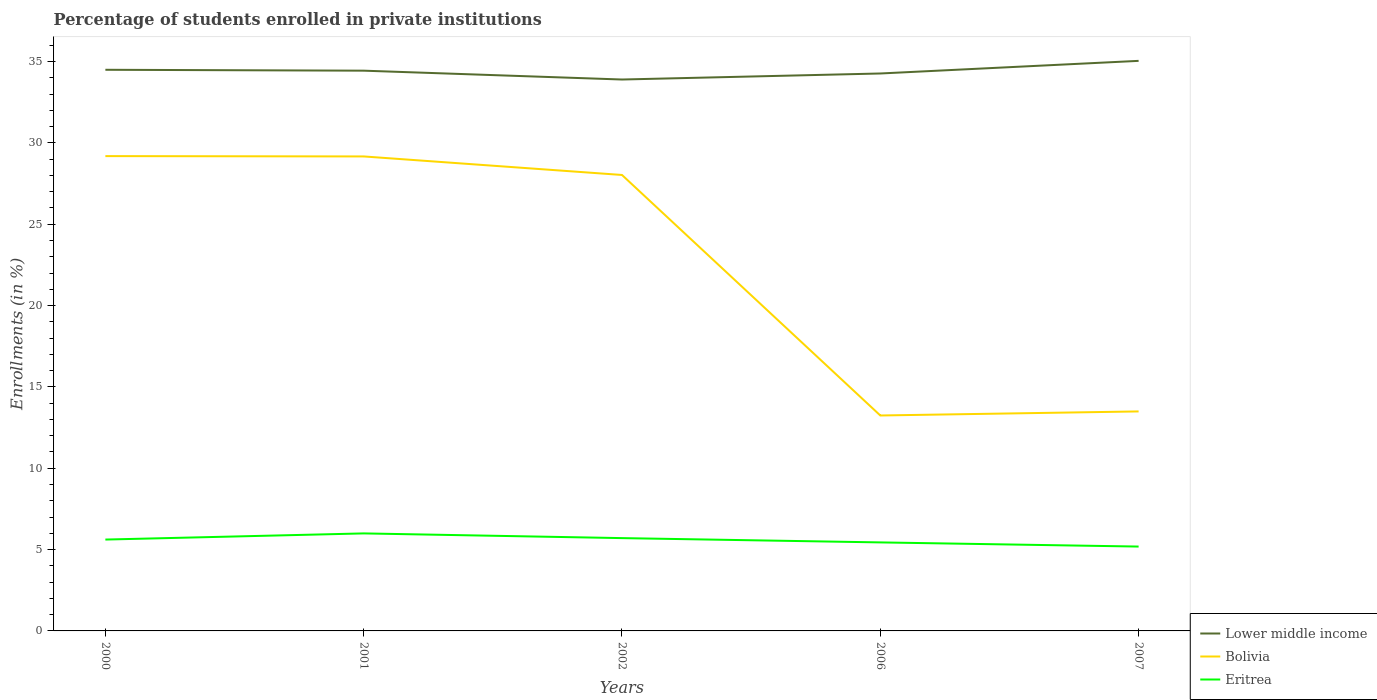Does the line corresponding to Bolivia intersect with the line corresponding to Eritrea?
Offer a very short reply. No. Across all years, what is the maximum percentage of trained teachers in Bolivia?
Your answer should be compact. 13.24. What is the total percentage of trained teachers in Lower middle income in the graph?
Your response must be concise. 0.54. What is the difference between the highest and the second highest percentage of trained teachers in Eritrea?
Offer a terse response. 0.81. What is the difference between the highest and the lowest percentage of trained teachers in Eritrea?
Keep it short and to the point. 3. Is the percentage of trained teachers in Bolivia strictly greater than the percentage of trained teachers in Eritrea over the years?
Your answer should be very brief. No. Are the values on the major ticks of Y-axis written in scientific E-notation?
Your answer should be compact. No. Does the graph contain any zero values?
Offer a very short reply. No. Does the graph contain grids?
Your response must be concise. No. Where does the legend appear in the graph?
Keep it short and to the point. Bottom right. How many legend labels are there?
Offer a terse response. 3. How are the legend labels stacked?
Offer a very short reply. Vertical. What is the title of the graph?
Ensure brevity in your answer.  Percentage of students enrolled in private institutions. Does "Bangladesh" appear as one of the legend labels in the graph?
Offer a terse response. No. What is the label or title of the Y-axis?
Your answer should be very brief. Enrollments (in %). What is the Enrollments (in %) in Lower middle income in 2000?
Ensure brevity in your answer.  34.49. What is the Enrollments (in %) in Bolivia in 2000?
Offer a very short reply. 29.19. What is the Enrollments (in %) of Eritrea in 2000?
Give a very brief answer. 5.62. What is the Enrollments (in %) in Lower middle income in 2001?
Your response must be concise. 34.44. What is the Enrollments (in %) in Bolivia in 2001?
Offer a terse response. 29.17. What is the Enrollments (in %) of Eritrea in 2001?
Provide a short and direct response. 5.99. What is the Enrollments (in %) in Lower middle income in 2002?
Provide a succinct answer. 33.89. What is the Enrollments (in %) of Bolivia in 2002?
Your answer should be compact. 28.03. What is the Enrollments (in %) in Eritrea in 2002?
Make the answer very short. 5.71. What is the Enrollments (in %) of Lower middle income in 2006?
Offer a terse response. 34.26. What is the Enrollments (in %) in Bolivia in 2006?
Offer a terse response. 13.24. What is the Enrollments (in %) of Eritrea in 2006?
Your answer should be compact. 5.44. What is the Enrollments (in %) in Lower middle income in 2007?
Ensure brevity in your answer.  35.04. What is the Enrollments (in %) of Bolivia in 2007?
Your answer should be very brief. 13.49. What is the Enrollments (in %) in Eritrea in 2007?
Provide a succinct answer. 5.19. Across all years, what is the maximum Enrollments (in %) of Lower middle income?
Give a very brief answer. 35.04. Across all years, what is the maximum Enrollments (in %) of Bolivia?
Give a very brief answer. 29.19. Across all years, what is the maximum Enrollments (in %) in Eritrea?
Provide a succinct answer. 5.99. Across all years, what is the minimum Enrollments (in %) in Lower middle income?
Your answer should be very brief. 33.89. Across all years, what is the minimum Enrollments (in %) in Bolivia?
Give a very brief answer. 13.24. Across all years, what is the minimum Enrollments (in %) of Eritrea?
Offer a very short reply. 5.19. What is the total Enrollments (in %) in Lower middle income in the graph?
Offer a terse response. 172.13. What is the total Enrollments (in %) in Bolivia in the graph?
Make the answer very short. 113.11. What is the total Enrollments (in %) of Eritrea in the graph?
Make the answer very short. 27.94. What is the difference between the Enrollments (in %) of Lower middle income in 2000 and that in 2001?
Provide a succinct answer. 0.06. What is the difference between the Enrollments (in %) of Bolivia in 2000 and that in 2001?
Ensure brevity in your answer.  0.02. What is the difference between the Enrollments (in %) in Eritrea in 2000 and that in 2001?
Your answer should be compact. -0.38. What is the difference between the Enrollments (in %) of Lower middle income in 2000 and that in 2002?
Ensure brevity in your answer.  0.6. What is the difference between the Enrollments (in %) of Bolivia in 2000 and that in 2002?
Offer a terse response. 1.16. What is the difference between the Enrollments (in %) of Eritrea in 2000 and that in 2002?
Your answer should be compact. -0.09. What is the difference between the Enrollments (in %) in Lower middle income in 2000 and that in 2006?
Your response must be concise. 0.23. What is the difference between the Enrollments (in %) in Bolivia in 2000 and that in 2006?
Provide a short and direct response. 15.94. What is the difference between the Enrollments (in %) of Eritrea in 2000 and that in 2006?
Your answer should be compact. 0.17. What is the difference between the Enrollments (in %) in Lower middle income in 2000 and that in 2007?
Provide a succinct answer. -0.55. What is the difference between the Enrollments (in %) in Bolivia in 2000 and that in 2007?
Provide a short and direct response. 15.69. What is the difference between the Enrollments (in %) of Eritrea in 2000 and that in 2007?
Your answer should be very brief. 0.43. What is the difference between the Enrollments (in %) of Lower middle income in 2001 and that in 2002?
Provide a succinct answer. 0.54. What is the difference between the Enrollments (in %) of Bolivia in 2001 and that in 2002?
Make the answer very short. 1.14. What is the difference between the Enrollments (in %) in Eritrea in 2001 and that in 2002?
Keep it short and to the point. 0.29. What is the difference between the Enrollments (in %) in Lower middle income in 2001 and that in 2006?
Keep it short and to the point. 0.17. What is the difference between the Enrollments (in %) of Bolivia in 2001 and that in 2006?
Ensure brevity in your answer.  15.92. What is the difference between the Enrollments (in %) in Eritrea in 2001 and that in 2006?
Provide a succinct answer. 0.55. What is the difference between the Enrollments (in %) in Lower middle income in 2001 and that in 2007?
Offer a terse response. -0.6. What is the difference between the Enrollments (in %) of Bolivia in 2001 and that in 2007?
Provide a short and direct response. 15.67. What is the difference between the Enrollments (in %) of Eritrea in 2001 and that in 2007?
Your answer should be compact. 0.81. What is the difference between the Enrollments (in %) in Lower middle income in 2002 and that in 2006?
Keep it short and to the point. -0.37. What is the difference between the Enrollments (in %) of Bolivia in 2002 and that in 2006?
Offer a very short reply. 14.78. What is the difference between the Enrollments (in %) of Eritrea in 2002 and that in 2006?
Keep it short and to the point. 0.26. What is the difference between the Enrollments (in %) in Lower middle income in 2002 and that in 2007?
Ensure brevity in your answer.  -1.15. What is the difference between the Enrollments (in %) of Bolivia in 2002 and that in 2007?
Your response must be concise. 14.53. What is the difference between the Enrollments (in %) of Eritrea in 2002 and that in 2007?
Offer a terse response. 0.52. What is the difference between the Enrollments (in %) of Lower middle income in 2006 and that in 2007?
Offer a very short reply. -0.78. What is the difference between the Enrollments (in %) in Bolivia in 2006 and that in 2007?
Your answer should be compact. -0.25. What is the difference between the Enrollments (in %) in Eritrea in 2006 and that in 2007?
Make the answer very short. 0.26. What is the difference between the Enrollments (in %) in Lower middle income in 2000 and the Enrollments (in %) in Bolivia in 2001?
Provide a short and direct response. 5.33. What is the difference between the Enrollments (in %) of Lower middle income in 2000 and the Enrollments (in %) of Eritrea in 2001?
Make the answer very short. 28.5. What is the difference between the Enrollments (in %) of Bolivia in 2000 and the Enrollments (in %) of Eritrea in 2001?
Offer a terse response. 23.19. What is the difference between the Enrollments (in %) in Lower middle income in 2000 and the Enrollments (in %) in Bolivia in 2002?
Provide a succinct answer. 6.47. What is the difference between the Enrollments (in %) of Lower middle income in 2000 and the Enrollments (in %) of Eritrea in 2002?
Make the answer very short. 28.79. What is the difference between the Enrollments (in %) of Bolivia in 2000 and the Enrollments (in %) of Eritrea in 2002?
Your answer should be very brief. 23.48. What is the difference between the Enrollments (in %) in Lower middle income in 2000 and the Enrollments (in %) in Bolivia in 2006?
Provide a short and direct response. 21.25. What is the difference between the Enrollments (in %) of Lower middle income in 2000 and the Enrollments (in %) of Eritrea in 2006?
Provide a succinct answer. 29.05. What is the difference between the Enrollments (in %) of Bolivia in 2000 and the Enrollments (in %) of Eritrea in 2006?
Make the answer very short. 23.74. What is the difference between the Enrollments (in %) in Lower middle income in 2000 and the Enrollments (in %) in Bolivia in 2007?
Your answer should be compact. 21. What is the difference between the Enrollments (in %) in Lower middle income in 2000 and the Enrollments (in %) in Eritrea in 2007?
Your response must be concise. 29.31. What is the difference between the Enrollments (in %) in Bolivia in 2000 and the Enrollments (in %) in Eritrea in 2007?
Offer a terse response. 24. What is the difference between the Enrollments (in %) of Lower middle income in 2001 and the Enrollments (in %) of Bolivia in 2002?
Make the answer very short. 6.41. What is the difference between the Enrollments (in %) of Lower middle income in 2001 and the Enrollments (in %) of Eritrea in 2002?
Your response must be concise. 28.73. What is the difference between the Enrollments (in %) of Bolivia in 2001 and the Enrollments (in %) of Eritrea in 2002?
Provide a succinct answer. 23.46. What is the difference between the Enrollments (in %) of Lower middle income in 2001 and the Enrollments (in %) of Bolivia in 2006?
Your response must be concise. 21.19. What is the difference between the Enrollments (in %) in Lower middle income in 2001 and the Enrollments (in %) in Eritrea in 2006?
Make the answer very short. 29. What is the difference between the Enrollments (in %) in Bolivia in 2001 and the Enrollments (in %) in Eritrea in 2006?
Provide a succinct answer. 23.72. What is the difference between the Enrollments (in %) in Lower middle income in 2001 and the Enrollments (in %) in Bolivia in 2007?
Provide a short and direct response. 20.95. What is the difference between the Enrollments (in %) in Lower middle income in 2001 and the Enrollments (in %) in Eritrea in 2007?
Offer a very short reply. 29.25. What is the difference between the Enrollments (in %) of Bolivia in 2001 and the Enrollments (in %) of Eritrea in 2007?
Make the answer very short. 23.98. What is the difference between the Enrollments (in %) in Lower middle income in 2002 and the Enrollments (in %) in Bolivia in 2006?
Make the answer very short. 20.65. What is the difference between the Enrollments (in %) in Lower middle income in 2002 and the Enrollments (in %) in Eritrea in 2006?
Ensure brevity in your answer.  28.45. What is the difference between the Enrollments (in %) of Bolivia in 2002 and the Enrollments (in %) of Eritrea in 2006?
Your answer should be compact. 22.59. What is the difference between the Enrollments (in %) in Lower middle income in 2002 and the Enrollments (in %) in Bolivia in 2007?
Give a very brief answer. 20.4. What is the difference between the Enrollments (in %) of Lower middle income in 2002 and the Enrollments (in %) of Eritrea in 2007?
Your response must be concise. 28.71. What is the difference between the Enrollments (in %) of Bolivia in 2002 and the Enrollments (in %) of Eritrea in 2007?
Give a very brief answer. 22.84. What is the difference between the Enrollments (in %) of Lower middle income in 2006 and the Enrollments (in %) of Bolivia in 2007?
Your answer should be compact. 20.77. What is the difference between the Enrollments (in %) in Lower middle income in 2006 and the Enrollments (in %) in Eritrea in 2007?
Make the answer very short. 29.08. What is the difference between the Enrollments (in %) of Bolivia in 2006 and the Enrollments (in %) of Eritrea in 2007?
Offer a very short reply. 8.06. What is the average Enrollments (in %) of Lower middle income per year?
Provide a succinct answer. 34.43. What is the average Enrollments (in %) in Bolivia per year?
Provide a short and direct response. 22.62. What is the average Enrollments (in %) of Eritrea per year?
Your answer should be very brief. 5.59. In the year 2000, what is the difference between the Enrollments (in %) of Lower middle income and Enrollments (in %) of Bolivia?
Give a very brief answer. 5.31. In the year 2000, what is the difference between the Enrollments (in %) in Lower middle income and Enrollments (in %) in Eritrea?
Your answer should be compact. 28.88. In the year 2000, what is the difference between the Enrollments (in %) of Bolivia and Enrollments (in %) of Eritrea?
Ensure brevity in your answer.  23.57. In the year 2001, what is the difference between the Enrollments (in %) of Lower middle income and Enrollments (in %) of Bolivia?
Your response must be concise. 5.27. In the year 2001, what is the difference between the Enrollments (in %) of Lower middle income and Enrollments (in %) of Eritrea?
Make the answer very short. 28.44. In the year 2001, what is the difference between the Enrollments (in %) in Bolivia and Enrollments (in %) in Eritrea?
Make the answer very short. 23.17. In the year 2002, what is the difference between the Enrollments (in %) in Lower middle income and Enrollments (in %) in Bolivia?
Provide a short and direct response. 5.87. In the year 2002, what is the difference between the Enrollments (in %) in Lower middle income and Enrollments (in %) in Eritrea?
Ensure brevity in your answer.  28.19. In the year 2002, what is the difference between the Enrollments (in %) in Bolivia and Enrollments (in %) in Eritrea?
Make the answer very short. 22.32. In the year 2006, what is the difference between the Enrollments (in %) in Lower middle income and Enrollments (in %) in Bolivia?
Offer a very short reply. 21.02. In the year 2006, what is the difference between the Enrollments (in %) of Lower middle income and Enrollments (in %) of Eritrea?
Give a very brief answer. 28.82. In the year 2006, what is the difference between the Enrollments (in %) in Bolivia and Enrollments (in %) in Eritrea?
Provide a succinct answer. 7.8. In the year 2007, what is the difference between the Enrollments (in %) of Lower middle income and Enrollments (in %) of Bolivia?
Offer a terse response. 21.55. In the year 2007, what is the difference between the Enrollments (in %) in Lower middle income and Enrollments (in %) in Eritrea?
Your answer should be very brief. 29.86. In the year 2007, what is the difference between the Enrollments (in %) in Bolivia and Enrollments (in %) in Eritrea?
Offer a terse response. 8.31. What is the ratio of the Enrollments (in %) in Eritrea in 2000 to that in 2001?
Keep it short and to the point. 0.94. What is the ratio of the Enrollments (in %) of Lower middle income in 2000 to that in 2002?
Your answer should be compact. 1.02. What is the ratio of the Enrollments (in %) in Bolivia in 2000 to that in 2002?
Offer a terse response. 1.04. What is the ratio of the Enrollments (in %) of Eritrea in 2000 to that in 2002?
Your response must be concise. 0.98. What is the ratio of the Enrollments (in %) of Lower middle income in 2000 to that in 2006?
Provide a short and direct response. 1.01. What is the ratio of the Enrollments (in %) in Bolivia in 2000 to that in 2006?
Offer a very short reply. 2.2. What is the ratio of the Enrollments (in %) of Eritrea in 2000 to that in 2006?
Ensure brevity in your answer.  1.03. What is the ratio of the Enrollments (in %) of Lower middle income in 2000 to that in 2007?
Ensure brevity in your answer.  0.98. What is the ratio of the Enrollments (in %) of Bolivia in 2000 to that in 2007?
Offer a very short reply. 2.16. What is the ratio of the Enrollments (in %) in Eritrea in 2000 to that in 2007?
Keep it short and to the point. 1.08. What is the ratio of the Enrollments (in %) of Lower middle income in 2001 to that in 2002?
Offer a terse response. 1.02. What is the ratio of the Enrollments (in %) of Bolivia in 2001 to that in 2002?
Provide a short and direct response. 1.04. What is the ratio of the Enrollments (in %) of Eritrea in 2001 to that in 2002?
Provide a short and direct response. 1.05. What is the ratio of the Enrollments (in %) in Bolivia in 2001 to that in 2006?
Offer a terse response. 2.2. What is the ratio of the Enrollments (in %) of Eritrea in 2001 to that in 2006?
Give a very brief answer. 1.1. What is the ratio of the Enrollments (in %) of Lower middle income in 2001 to that in 2007?
Keep it short and to the point. 0.98. What is the ratio of the Enrollments (in %) in Bolivia in 2001 to that in 2007?
Your answer should be very brief. 2.16. What is the ratio of the Enrollments (in %) in Eritrea in 2001 to that in 2007?
Your answer should be very brief. 1.16. What is the ratio of the Enrollments (in %) of Lower middle income in 2002 to that in 2006?
Provide a short and direct response. 0.99. What is the ratio of the Enrollments (in %) in Bolivia in 2002 to that in 2006?
Give a very brief answer. 2.12. What is the ratio of the Enrollments (in %) of Eritrea in 2002 to that in 2006?
Keep it short and to the point. 1.05. What is the ratio of the Enrollments (in %) in Lower middle income in 2002 to that in 2007?
Keep it short and to the point. 0.97. What is the ratio of the Enrollments (in %) in Bolivia in 2002 to that in 2007?
Offer a very short reply. 2.08. What is the ratio of the Enrollments (in %) in Eritrea in 2002 to that in 2007?
Make the answer very short. 1.1. What is the ratio of the Enrollments (in %) in Lower middle income in 2006 to that in 2007?
Keep it short and to the point. 0.98. What is the ratio of the Enrollments (in %) of Bolivia in 2006 to that in 2007?
Provide a succinct answer. 0.98. What is the ratio of the Enrollments (in %) in Eritrea in 2006 to that in 2007?
Provide a succinct answer. 1.05. What is the difference between the highest and the second highest Enrollments (in %) of Lower middle income?
Provide a succinct answer. 0.55. What is the difference between the highest and the second highest Enrollments (in %) of Bolivia?
Your response must be concise. 0.02. What is the difference between the highest and the second highest Enrollments (in %) of Eritrea?
Keep it short and to the point. 0.29. What is the difference between the highest and the lowest Enrollments (in %) of Lower middle income?
Provide a succinct answer. 1.15. What is the difference between the highest and the lowest Enrollments (in %) in Bolivia?
Provide a succinct answer. 15.94. What is the difference between the highest and the lowest Enrollments (in %) in Eritrea?
Your answer should be compact. 0.81. 